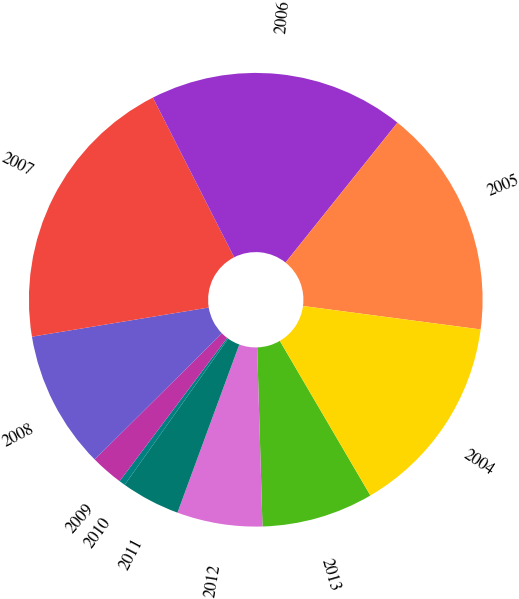<chart> <loc_0><loc_0><loc_500><loc_500><pie_chart><fcel>2013<fcel>2012<fcel>2011<fcel>2010<fcel>2009<fcel>2008<fcel>2007<fcel>2006<fcel>2005<fcel>2004<nl><fcel>7.96%<fcel>6.08%<fcel>4.2%<fcel>0.44%<fcel>2.32%<fcel>9.83%<fcel>20.11%<fcel>18.23%<fcel>16.35%<fcel>14.48%<nl></chart> 